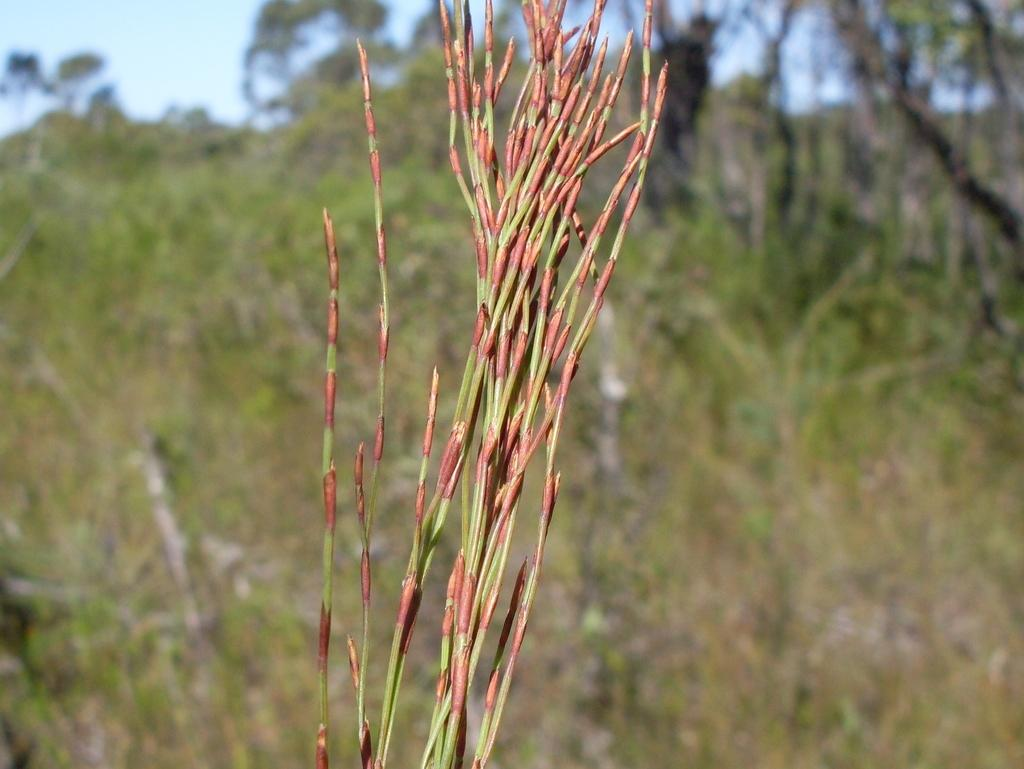What is located in the foreground of the image? There is a plant in the foreground of the image. What colors can be seen on the plant? The plant has green and red colors. What can be seen in the background of the image? There are trees in the background of the image. What is visible at the top of the image? The sky is visible at the top of the image. What is the opinion of the dime about the plant in the image? There is no dime present in the image, and therefore no opinion can be attributed to it. 